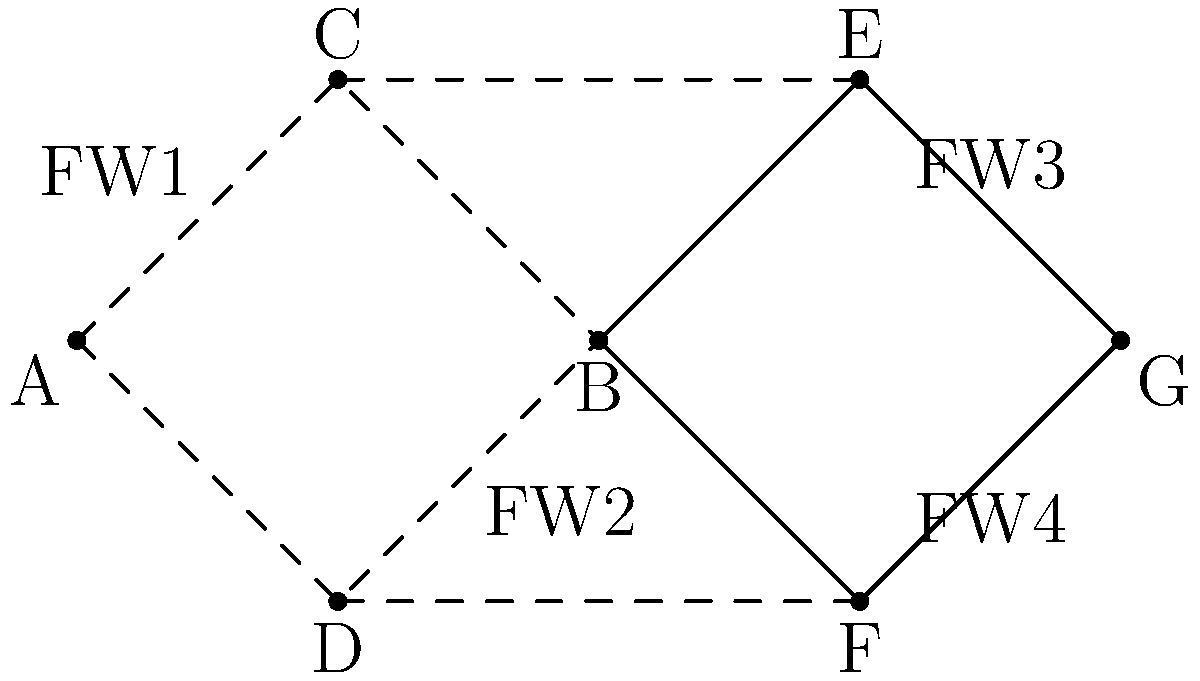In the given network topology, which critical component should be implemented to ensure both fault-tolerance and security, considering that nodes C and D are in a demilitarized zone (DMZ)? To answer this question, let's analyze the topology and consider the requirements for fault-tolerance and security:

1. Fault-tolerance:
   - The network has redundant paths between key nodes (A-B-C-D forms a mesh).
   - There are multiple routes from the internal network (A-B) to the external network (G).

2. Security:
   - Nodes C and D are in a DMZ, which requires careful security implementation.
   - There are multiple firewalls (FW1, FW2, FW3, FW4) protecting different network segments.

3. Critical component for both fault-tolerance and security:
   - Given that C and D are in the DMZ, they need to be protected while allowing necessary traffic.
   - The firewalls FW1 and FW2 are crucial for controlling traffic between the internal network, DMZ, and external network.

4. Implementing a stateful firewall cluster:
   - By clustering FW1 and FW2, we can achieve both fault-tolerance and enhanced security.
   - If one firewall fails, the other can take over, ensuring continuous protection.
   - The cluster can intelligently manage traffic between the internal network, DMZ, and external network.
   - It can enforce strict security policies while allowing necessary communication with the DMZ.

5. Additional benefits:
   - Load balancing between FW1 and FW2 can improve performance.
   - Centralized management of the firewall cluster simplifies security policy enforcement.

Therefore, the critical component to implement is a stateful firewall cluster combining FW1 and FW2.
Answer: Stateful firewall cluster (FW1 and FW2) 